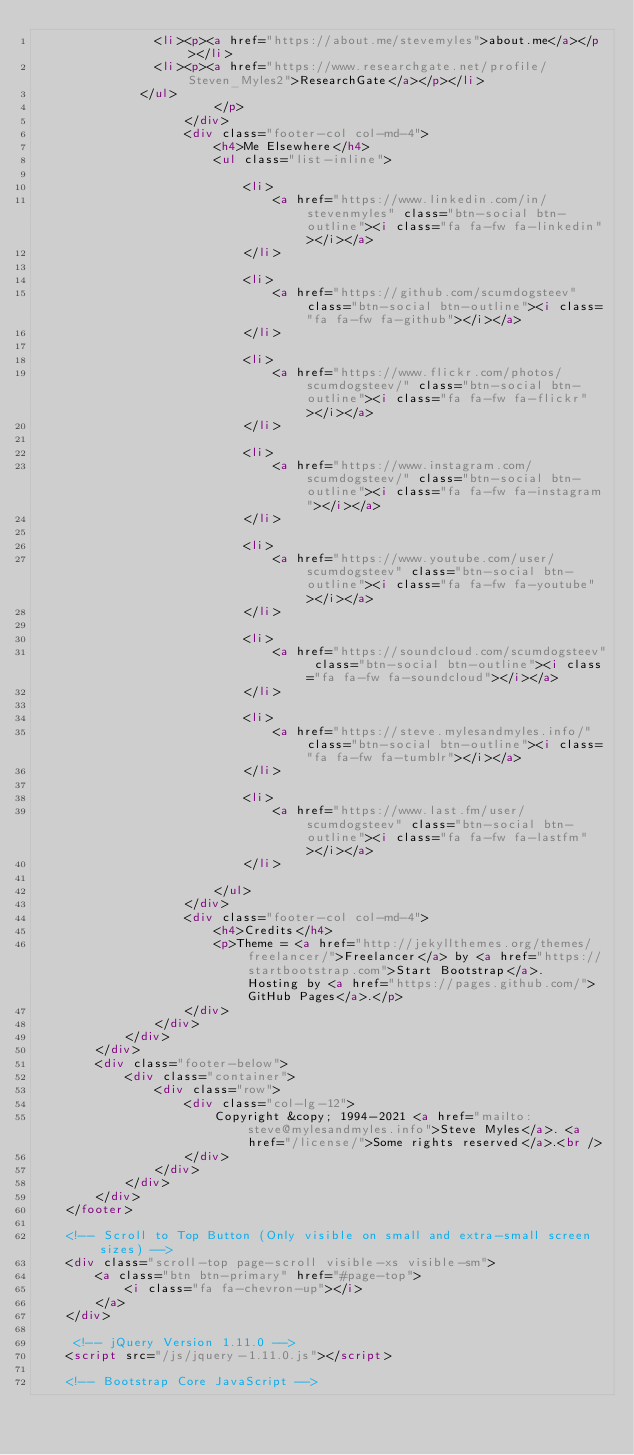Convert code to text. <code><loc_0><loc_0><loc_500><loc_500><_HTML_>								<li><p><a href="https://about.me/stevemyles">about.me</a></p></li>
								<li><p><a href="https://www.researchgate.net/profile/Steven_Myles2">ResearchGate</a></p></li>
							</ul>	
                        </p>
                    </div>
                    <div class="footer-col col-md-4">
                        <h4>Me Elsewhere</h4>
                        <ul class="list-inline">
                            
                            <li>
                                <a href="https://www.linkedin.com/in/stevenmyles" class="btn-social btn-outline"><i class="fa fa-fw fa-linkedin"></i></a>
                            </li>
		                    
                            <li>
                                <a href="https://github.com/scumdogsteev" class="btn-social btn-outline"><i class="fa fa-fw fa-github"></i></a>
                            </li>
		                    
                            <li>
                                <a href="https://www.flickr.com/photos/scumdogsteev/" class="btn-social btn-outline"><i class="fa fa-fw fa-flickr"></i></a>
                            </li>
		                    
                            <li>
                                <a href="https://www.instagram.com/scumdogsteev/" class="btn-social btn-outline"><i class="fa fa-fw fa-instagram"></i></a>
                            </li>
		                    
                            <li>
                                <a href="https://www.youtube.com/user/scumdogsteev" class="btn-social btn-outline"><i class="fa fa-fw fa-youtube"></i></a>
                            </li>
		                    
                            <li>
                                <a href="https://soundcloud.com/scumdogsteev" class="btn-social btn-outline"><i class="fa fa-fw fa-soundcloud"></i></a>
                            </li>
		                    
                            <li>
                                <a href="https://steve.mylesandmyles.info/" class="btn-social btn-outline"><i class="fa fa-fw fa-tumblr"></i></a>
                            </li>
		                    
                            <li>
                                <a href="https://www.last.fm/user/scumdogsteev" class="btn-social btn-outline"><i class="fa fa-fw fa-lastfm"></i></a>
                            </li>
		                    
                        </ul>
                    </div>
                    <div class="footer-col col-md-4">
                        <h4>Credits</h4>
                        <p>Theme = <a href="http://jekyllthemes.org/themes/freelancer/">Freelancer</a> by <a href="https://startbootstrap.com">Start Bootstrap</a>.  Hosting by <a href="https://pages.github.com/">GitHub Pages</a>.</p>
                    </div>
                </div>
            </div>
        </div>
        <div class="footer-below">
            <div class="container">
                <div class="row">
                    <div class="col-lg-12">
                        Copyright &copy; 1994-2021 <a href="mailto:steve@mylesandmyles.info">Steve Myles</a>. <a href="/license/">Some rights reserved</a>.<br />
                    </div>
                </div>
            </div>
        </div>
    </footer>

    <!-- Scroll to Top Button (Only visible on small and extra-small screen sizes) -->
    <div class="scroll-top page-scroll visible-xs visible-sm">
        <a class="btn btn-primary" href="#page-top">
            <i class="fa fa-chevron-up"></i>
        </a>
    </div>

     <!-- jQuery Version 1.11.0 -->
    <script src="/js/jquery-1.11.0.js"></script>

    <!-- Bootstrap Core JavaScript --></code> 